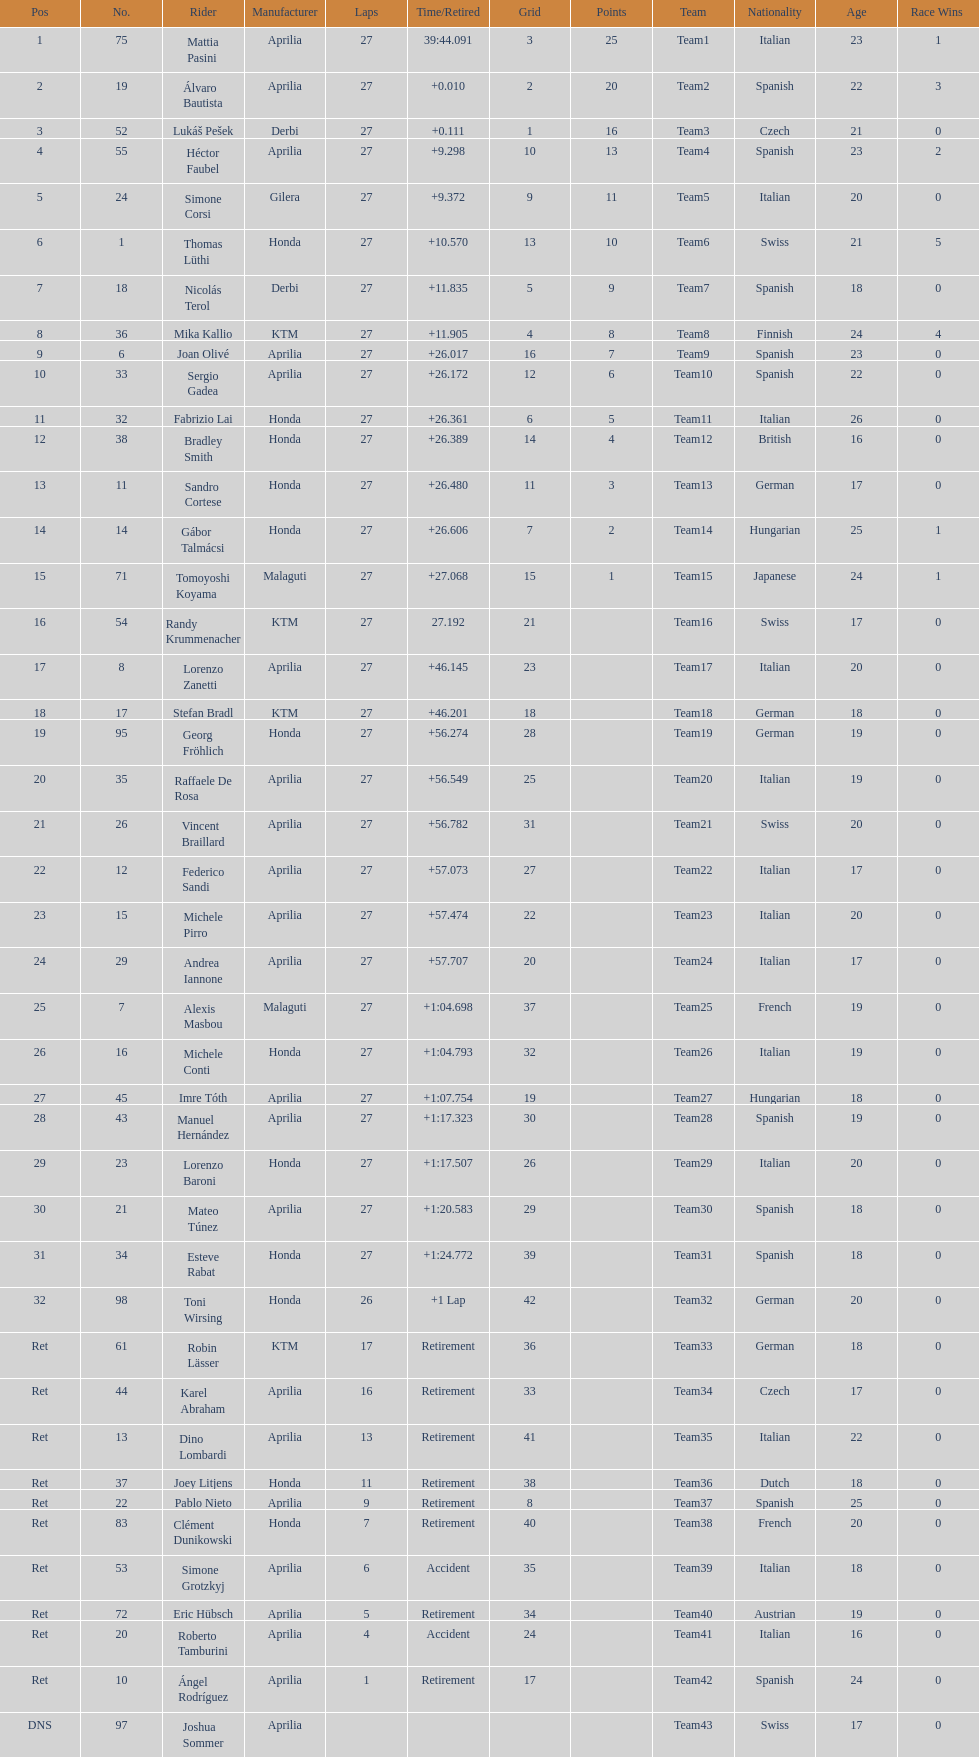What was the total number of positions in the 125cc classification? 43. 